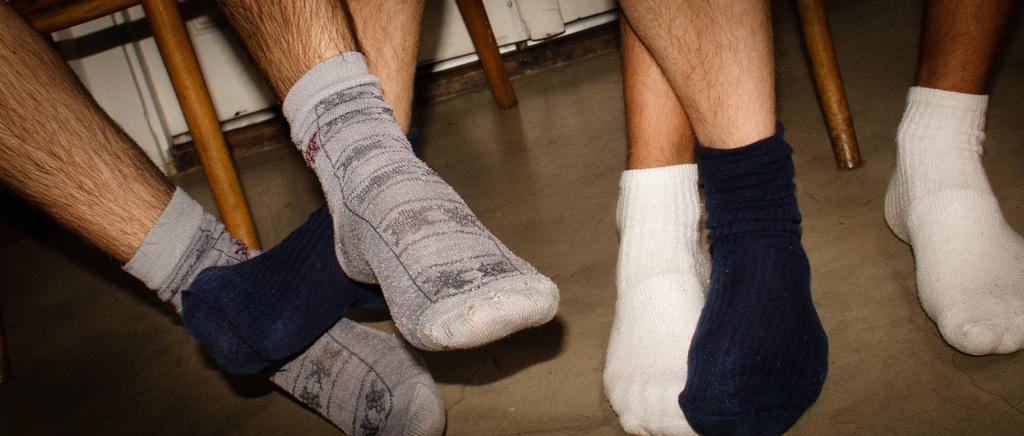What body parts are visible in the image? There are human legs visible in the image. What type of club is the kitten holding in the image? There is no kitten or club present in the image; only human legs are visible. 